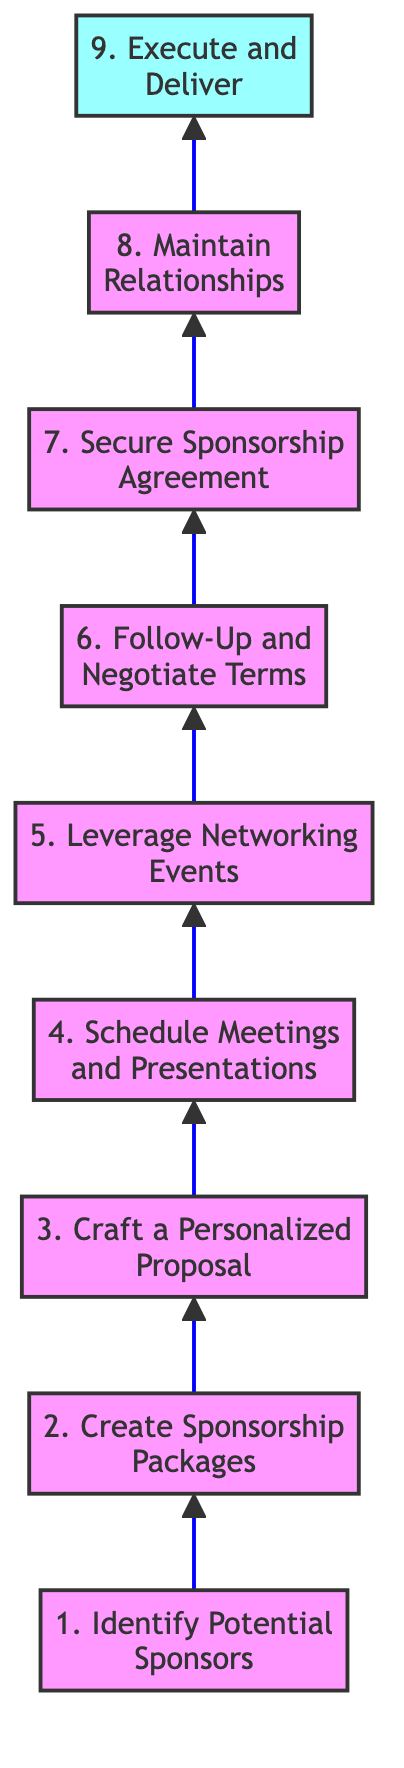What is the first step in the diagram? The first step in the diagram is labeled as "Identify Potential Sponsors." It's the bottom-most node, indicating it's the starting point of the flowchart.
Answer: Identify Potential Sponsors What is the last step in the diagram? The last step, located at the top of the diagram, is labeled "Execute and Deliver." It indicates the final action to be taken.
Answer: Execute and Deliver How many total steps are outlined in the diagram? By counting the nodes listed in the diagram, there are nine distinct steps, indicating the range of actions to be followed.
Answer: 9 What is the relationship between "Create Sponsorship Packages" and "Craft a Personalized Proposal"? "Create Sponsorship Packages" is the second step, which directly precedes "Craft a Personalized Proposal," making them sequentially related in the sponsorship process.
Answer: Sequentially related Which step involves regular follow-up with interested businesses? The step dedicated to this action is "Follow-Up and Negotiate Terms." It specifically highlights the importance of communication with potential sponsors.
Answer: Follow-Up and Negotiate Terms What is necessary to finalize a sponsorship according to the diagram? To finalize a sponsorship, the step labeled "Secure Sponsorship Agreement" must be completed, which entails getting both parties to agree on the terms.
Answer: Secure Sponsorship Agreement Which event type should participants leverage for networking according to the diagram? Participants should leverage "industry conferences, charity galas, and networking events" as indicated in the step "Leverage Networking Events."
Answer: Networking events Why is "Maintain Relationships" crucial in the sponsorship process? This step emphasizes the importance of ongoing communication and gratitude towards sponsors to foster long-term partnerships, which benefits future sponsorship efforts.
Answer: Foster long-term partnerships 